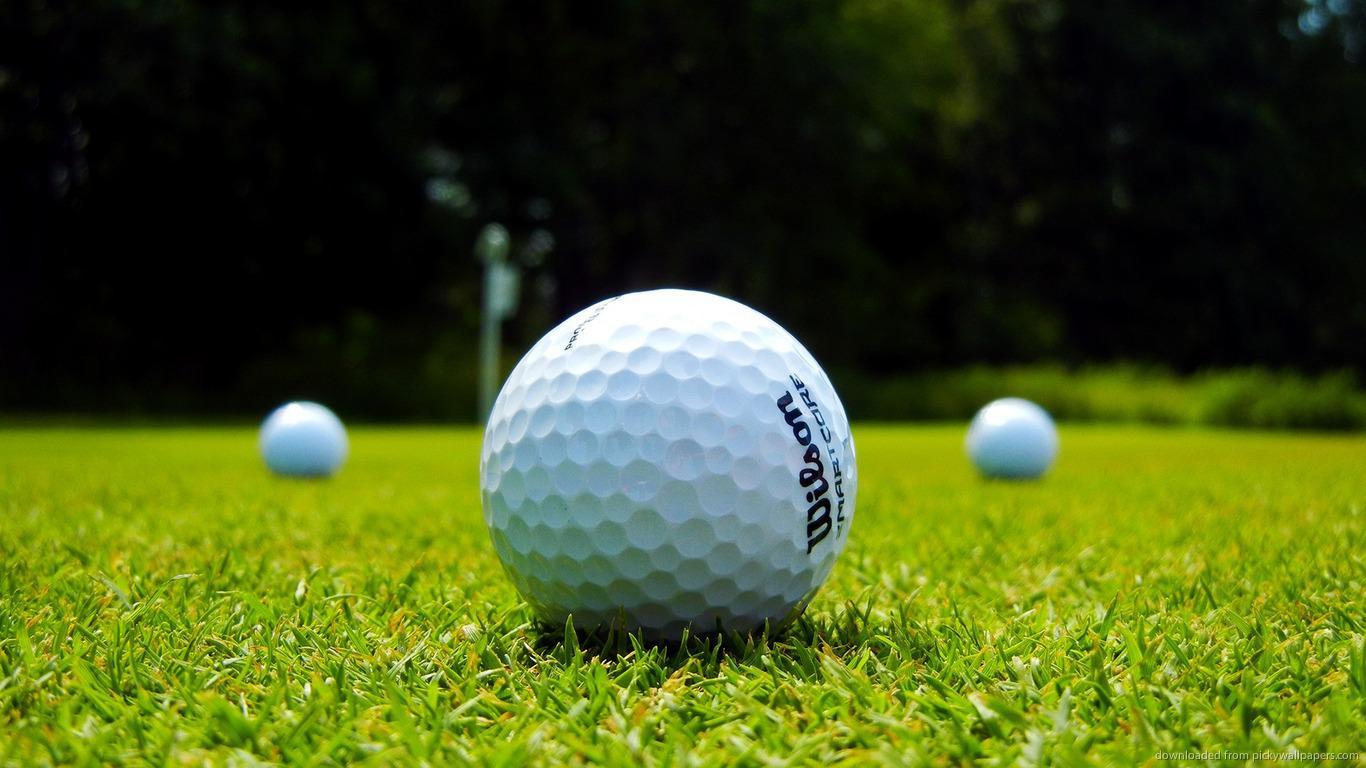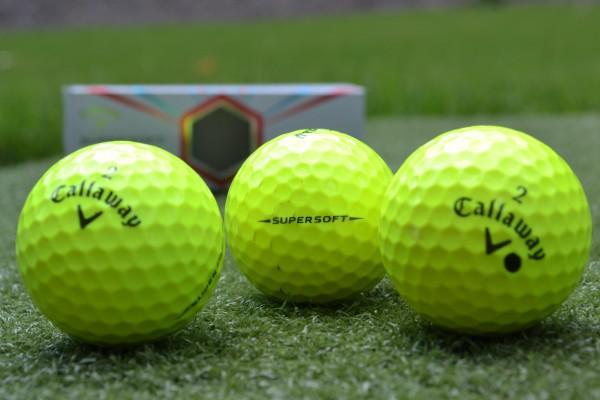The first image is the image on the left, the second image is the image on the right. Given the left and right images, does the statement "An image shows one golf ball next to a hole that does not have a pole in it." hold true? Answer yes or no. No. The first image is the image on the left, the second image is the image on the right. For the images shown, is this caption "There is a ball near the hole in at least one of the images." true? Answer yes or no. No. 